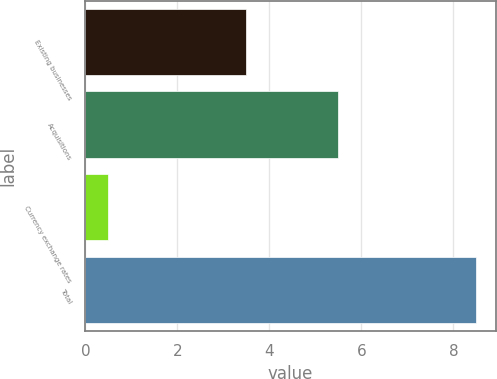<chart> <loc_0><loc_0><loc_500><loc_500><bar_chart><fcel>Existing businesses<fcel>Acquisitions<fcel>Currency exchange rates<fcel>Total<nl><fcel>3.5<fcel>5.5<fcel>0.5<fcel>8.5<nl></chart> 